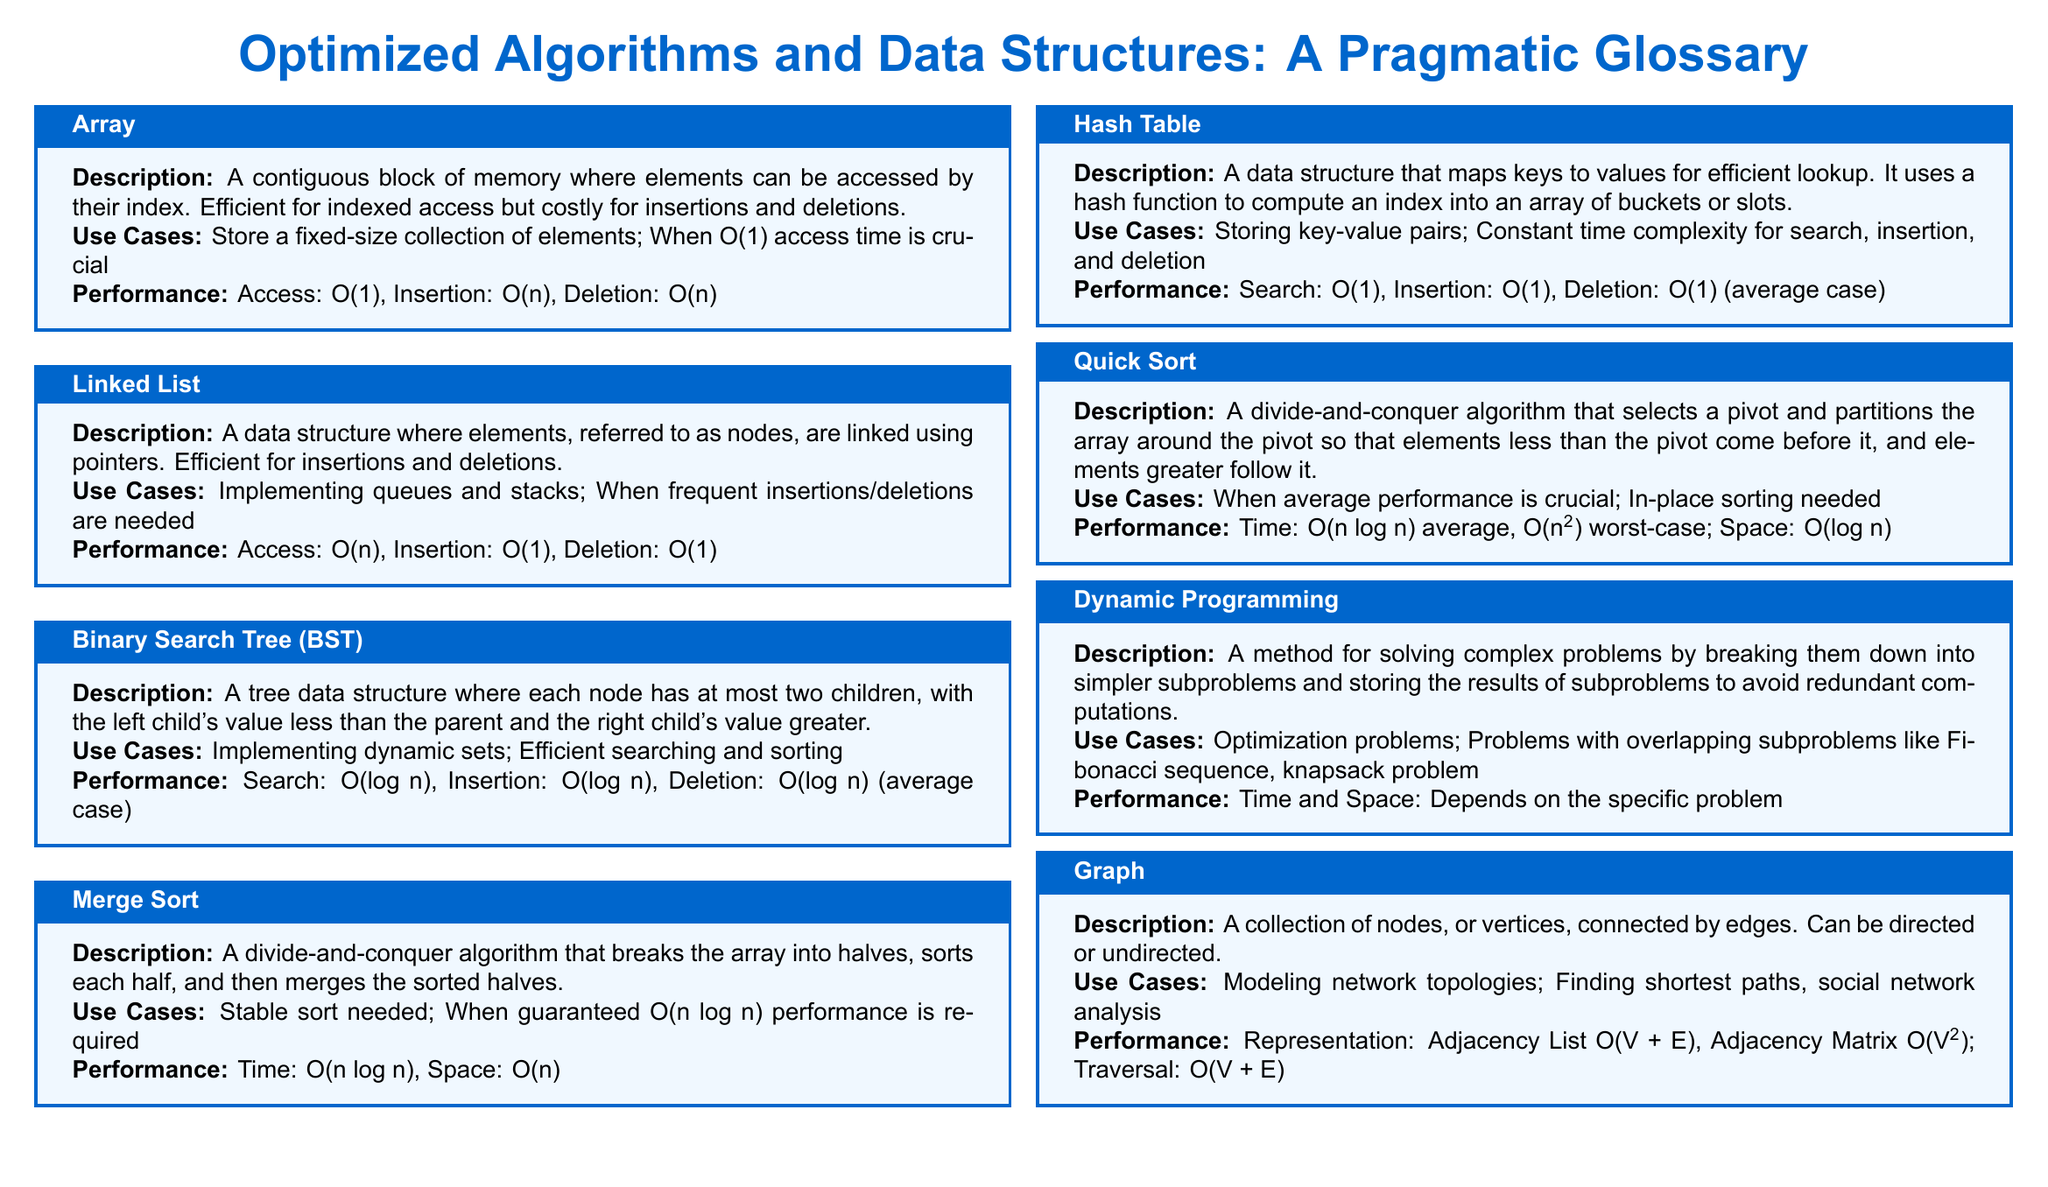What is the data structure that allows O(1) insertion and deletion? The linked list is efficient for insertions and deletions, allowing O(1) time complexity for these operations.
Answer: Linked List What is the time complexity for accessing an element in an array? Accessing an element in an array is efficient and has a time complexity of O(1).
Answer: O(1) What sorting algorithm guarantees O(n log n) performance? Merge sort is a divide-and-conquer algorithm that guarantees O(n log n) time complexity.
Answer: Merge Sort What is the worst-case time complexity of quick sort? The worst-case time complexity of quick sort can be O(n squared) under certain conditions.
Answer: O(n squared) What data structure is used for mapping keys to values? A hash table is a data structure that maps keys to values for efficient lookup.
Answer: Hash Table Which algorithm is useful for optimization problems with overlapping subproblems? Dynamic programming is specifically designed for optimization problems that involve overlapping subproblems.
Answer: Dynamic Programming What is the average case time complexity for searching in a hash table? On average, searching in a hash table has a time complexity of O(1).
Answer: O(1) What does a binary search tree allow in terms of searching? A binary search tree allows efficient searching with an average time complexity of O(log n).
Answer: O(log n) What representation of a graph has a time complexity of O(V squared)? The adjacency matrix representation of a graph results in a time complexity of O(V squared).
Answer: O(V squared) 